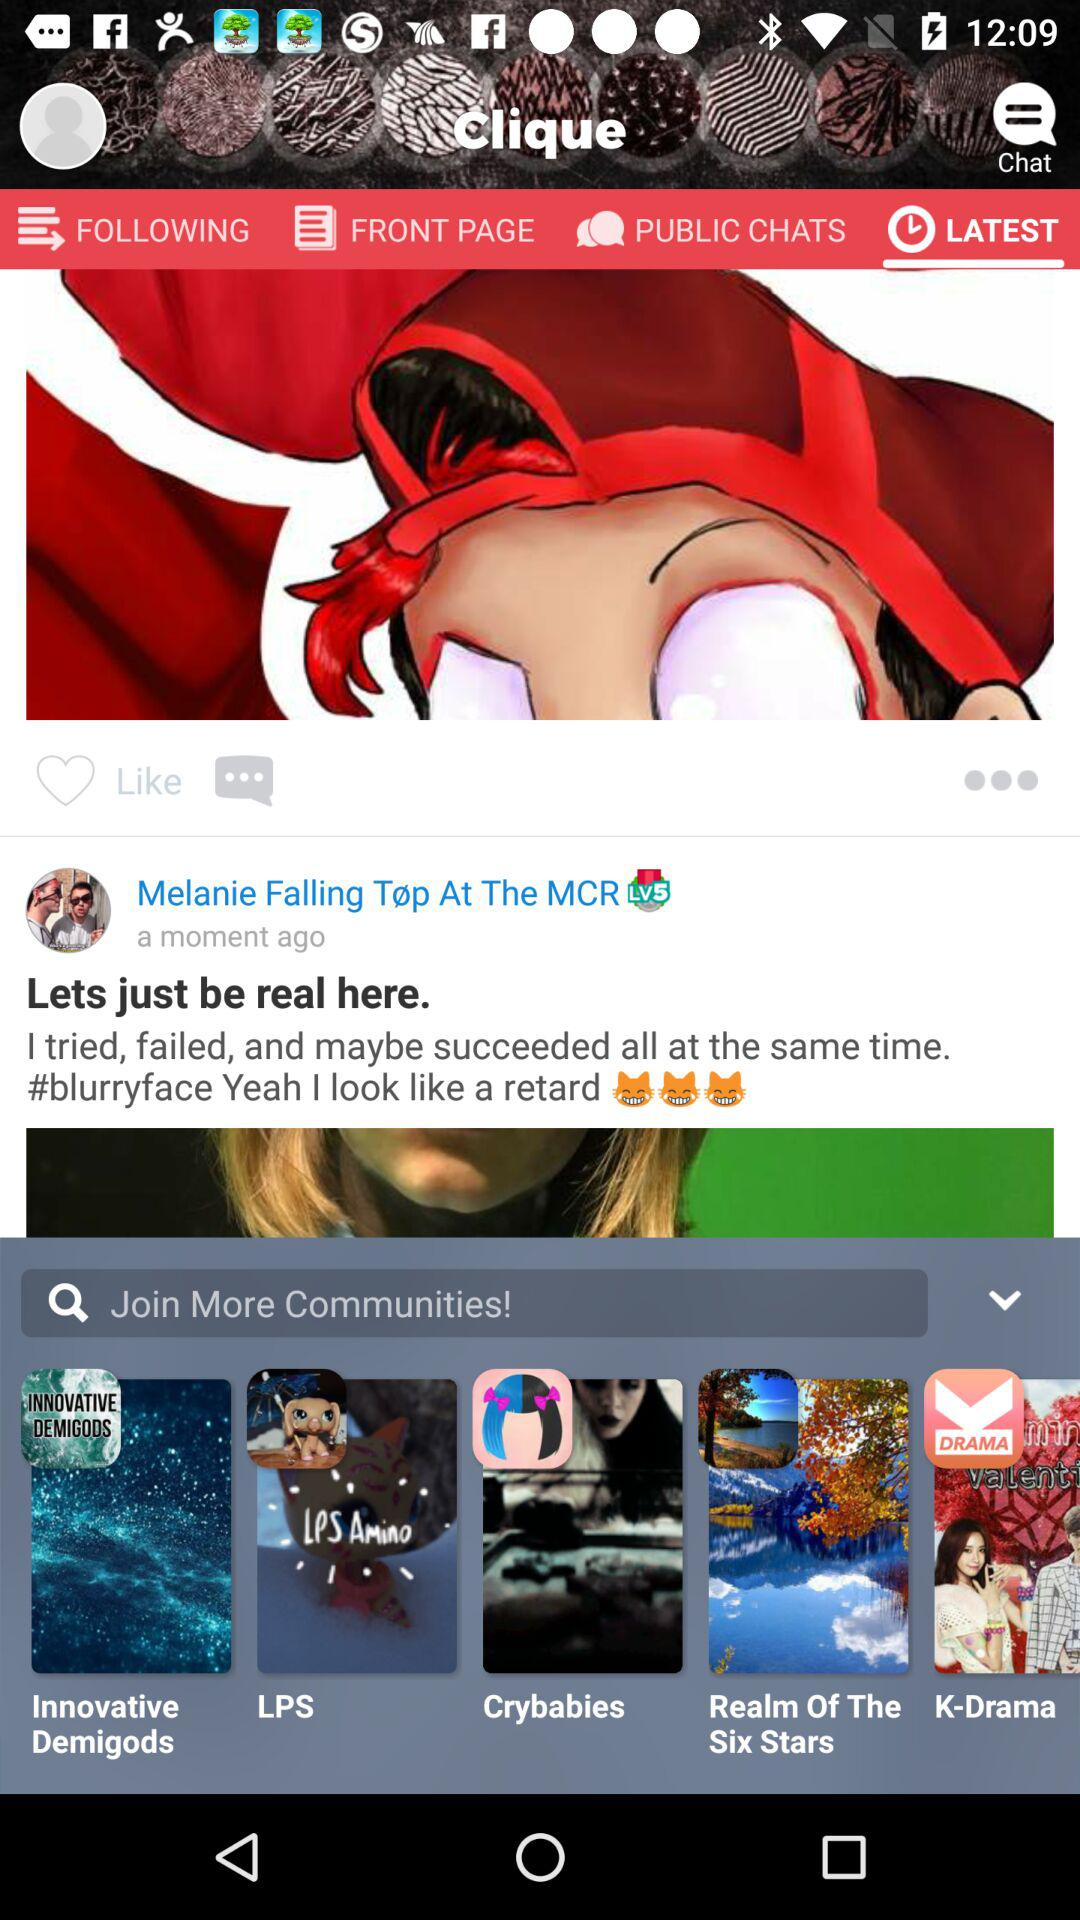Which tab is selected? The selected tab is "LATEST". 